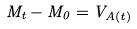<formula> <loc_0><loc_0><loc_500><loc_500>M _ { t } - M _ { 0 } = V _ { A ( t ) }</formula> 